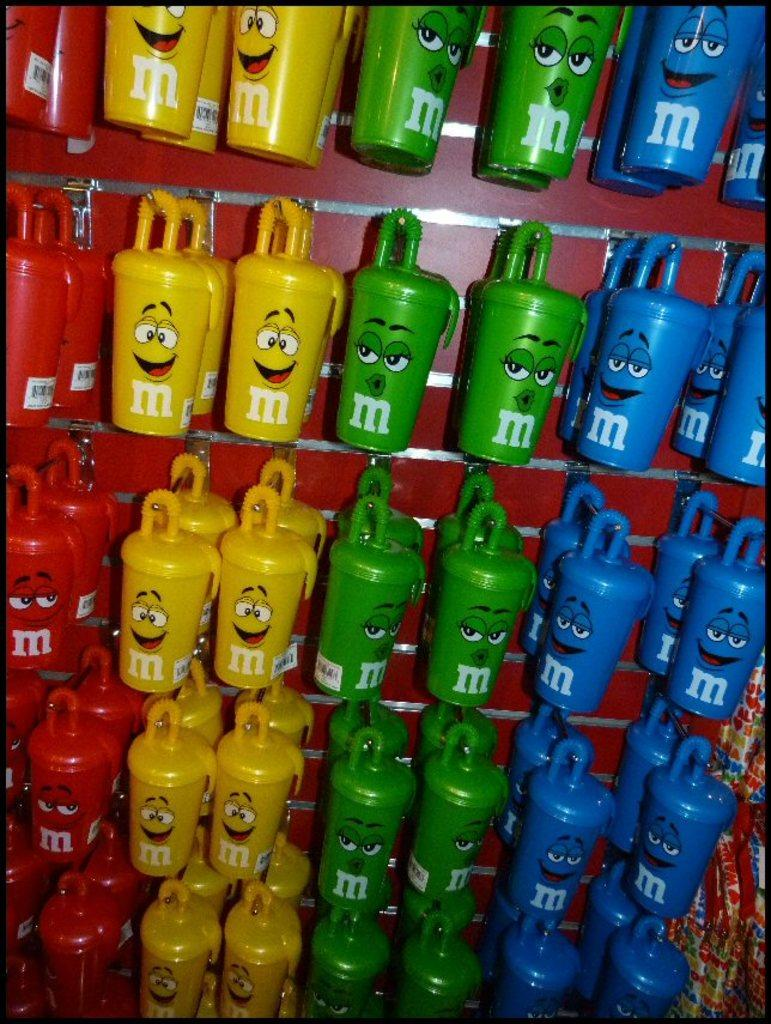What is the primary subject of the image? The primary subject of the image is many bottles. Can you describe the bottles in the image? Unfortunately, the facts provided do not give any specific details about the bottles. Are there any other objects or elements in the image besides the bottles? The facts provided do not mention any other objects or elements in the image. What type of dog can be seen playing with a cast in the image? There is no dog or cast present in the image; it only features many bottles. 